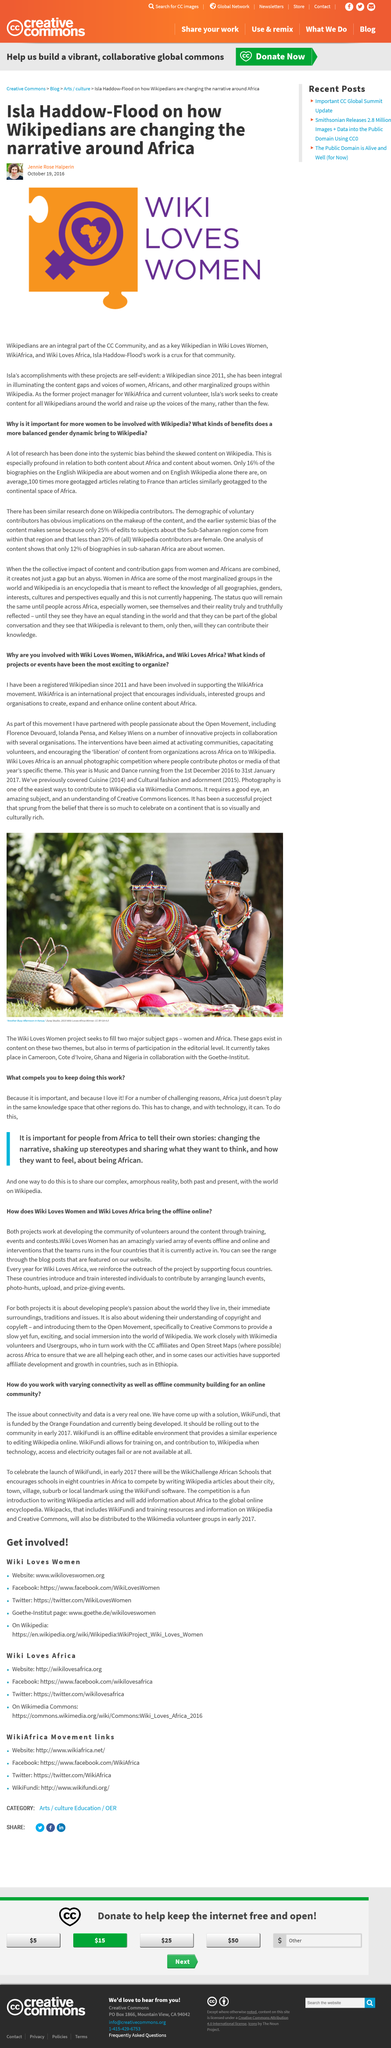Outline some significant characteristics in this image. Isla was the former project manager for WikiAfrica. WikiFundi, a website designed to assist individuals in countries such as Africa, was created with the intention of providing valuable resources and tools for those in need. This article was written on October 19, 2016, as evidenced by the provided date. What is being celebrated to mark the launch of WikiFundi? WikiChallenge is being hosted. Jennie Rose Halperin is the author of this article. 